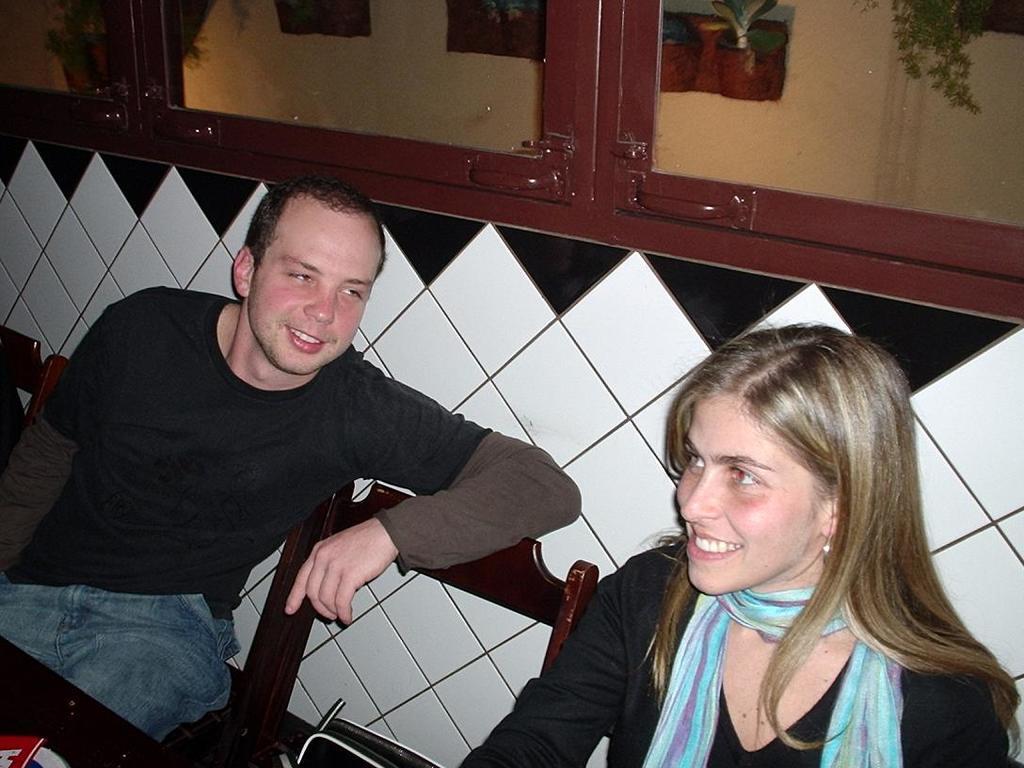In one or two sentences, can you explain what this image depicts? In this picture there are two people sitting on chairs and smiling. We can see objects on the platform. In the background of the image we can see glass windows, through these glass windows we can see house plants and wall. 